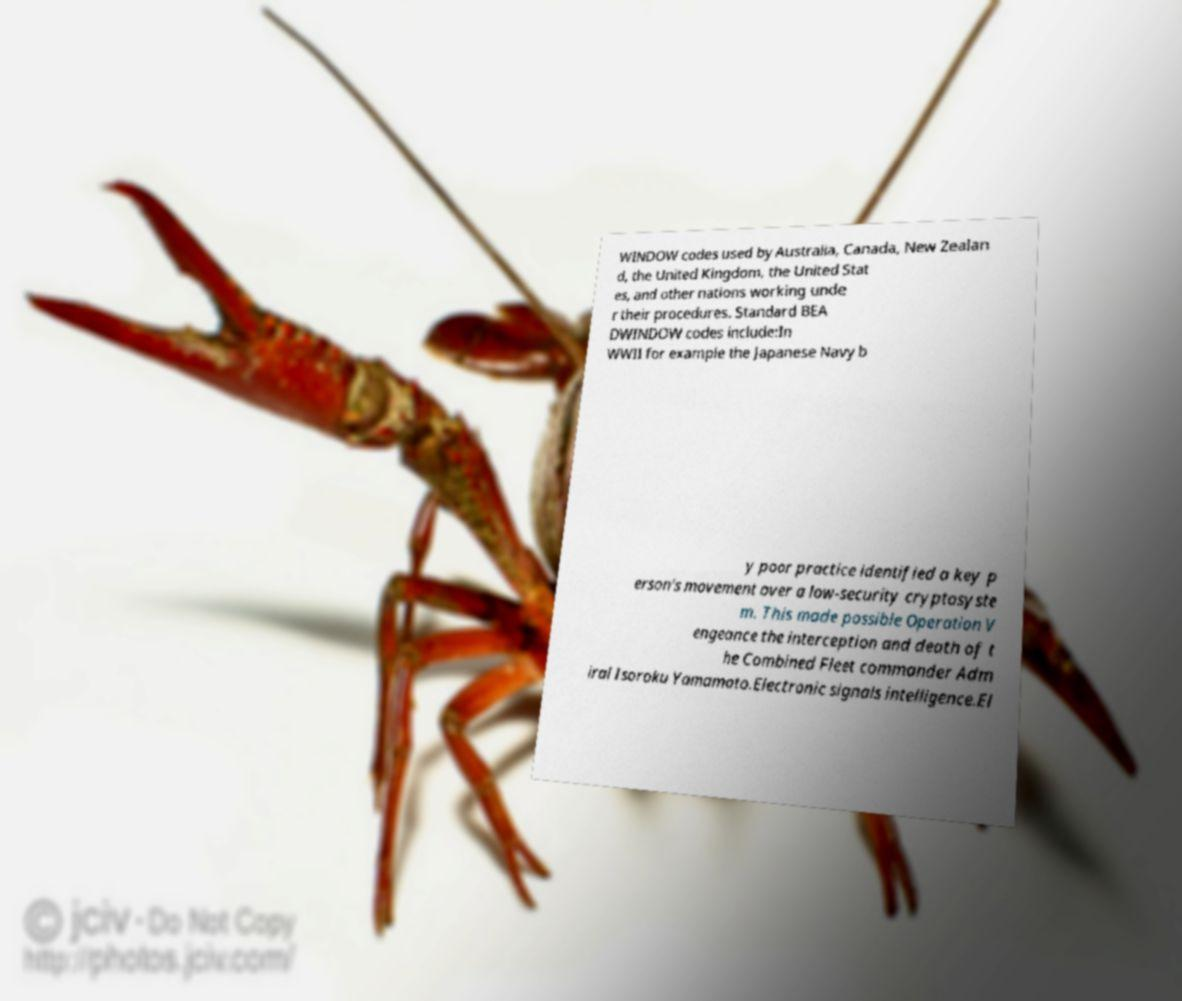I need the written content from this picture converted into text. Can you do that? WINDOW codes used by Australia, Canada, New Zealan d, the United Kingdom, the United Stat es, and other nations working unde r their procedures. Standard BEA DWINDOW codes include:In WWII for example the Japanese Navy b y poor practice identified a key p erson's movement over a low-security cryptosyste m. This made possible Operation V engeance the interception and death of t he Combined Fleet commander Adm iral Isoroku Yamamoto.Electronic signals intelligence.El 